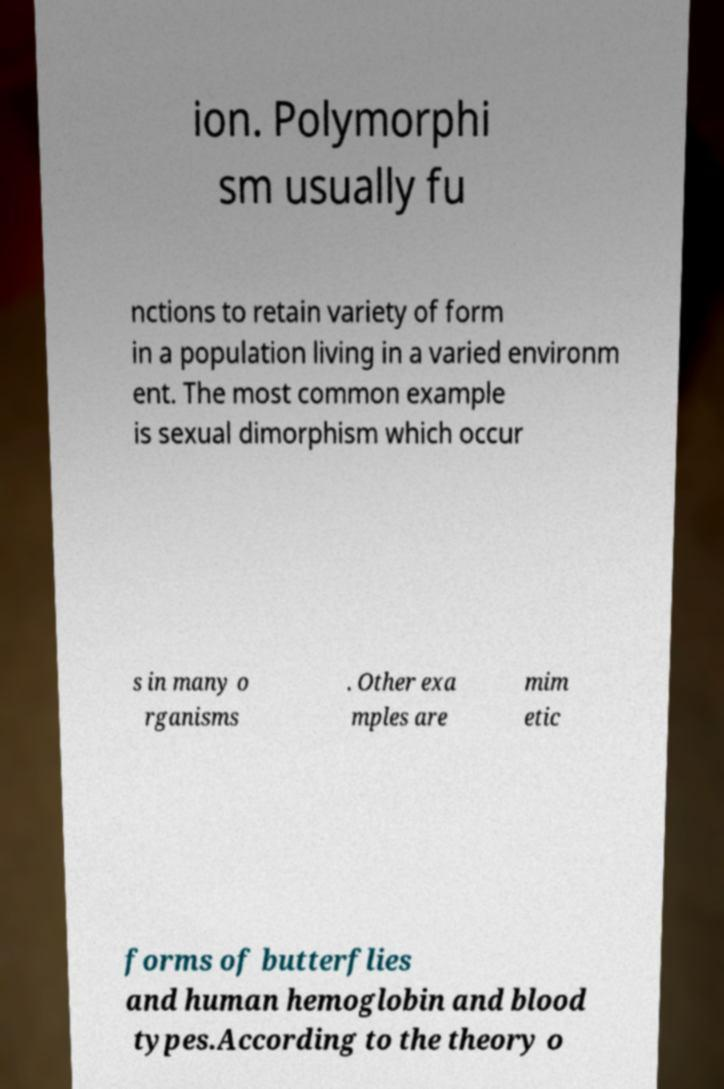Can you read and provide the text displayed in the image?This photo seems to have some interesting text. Can you extract and type it out for me? ion. Polymorphi sm usually fu nctions to retain variety of form in a population living in a varied environm ent. The most common example is sexual dimorphism which occur s in many o rganisms . Other exa mples are mim etic forms of butterflies and human hemoglobin and blood types.According to the theory o 